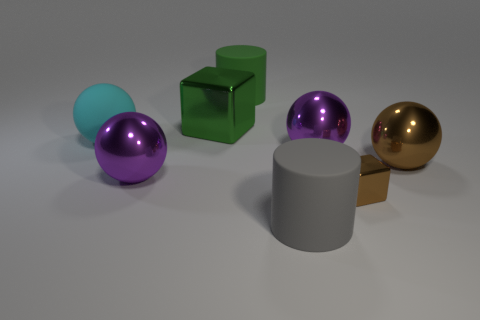Subtract all big matte balls. How many balls are left? 3 Subtract all purple spheres. How many spheres are left? 2 Subtract all purple blocks. How many purple balls are left? 2 Add 2 big green rubber cylinders. How many objects exist? 10 Subtract all cylinders. How many objects are left? 6 Subtract 1 spheres. How many spheres are left? 3 Add 4 big green shiny cubes. How many big green shiny cubes are left? 5 Add 2 brown shiny things. How many brown shiny things exist? 4 Subtract 0 yellow cylinders. How many objects are left? 8 Subtract all cyan cylinders. Subtract all brown cubes. How many cylinders are left? 2 